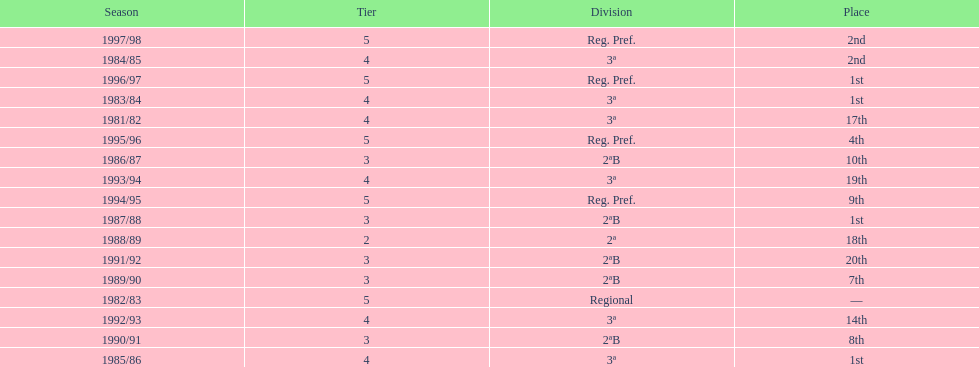How many seasons are shown in this chart? 17. 